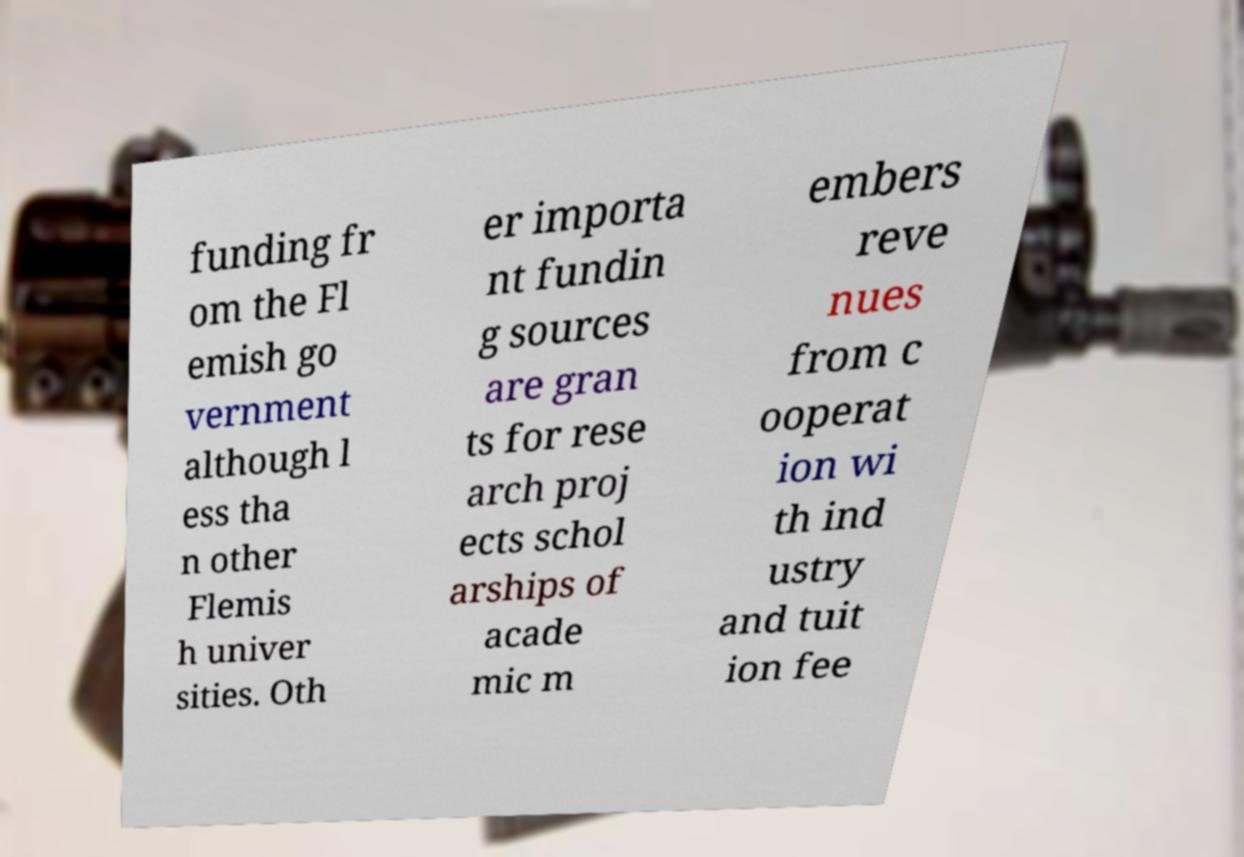Could you extract and type out the text from this image? funding fr om the Fl emish go vernment although l ess tha n other Flemis h univer sities. Oth er importa nt fundin g sources are gran ts for rese arch proj ects schol arships of acade mic m embers reve nues from c ooperat ion wi th ind ustry and tuit ion fee 